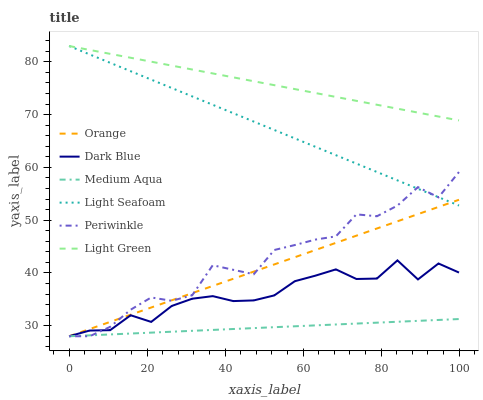Does Medium Aqua have the minimum area under the curve?
Answer yes or no. Yes. Does Light Green have the maximum area under the curve?
Answer yes or no. Yes. Does Periwinkle have the minimum area under the curve?
Answer yes or no. No. Does Periwinkle have the maximum area under the curve?
Answer yes or no. No. Is Medium Aqua the smoothest?
Answer yes or no. Yes. Is Periwinkle the roughest?
Answer yes or no. Yes. Is Light Green the smoothest?
Answer yes or no. No. Is Light Green the roughest?
Answer yes or no. No. Does Dark Blue have the lowest value?
Answer yes or no. Yes. Does Light Green have the lowest value?
Answer yes or no. No. Does Light Seafoam have the highest value?
Answer yes or no. Yes. Does Periwinkle have the highest value?
Answer yes or no. No. Is Dark Blue less than Light Green?
Answer yes or no. Yes. Is Light Seafoam greater than Dark Blue?
Answer yes or no. Yes. Does Light Seafoam intersect Periwinkle?
Answer yes or no. Yes. Is Light Seafoam less than Periwinkle?
Answer yes or no. No. Is Light Seafoam greater than Periwinkle?
Answer yes or no. No. Does Dark Blue intersect Light Green?
Answer yes or no. No. 